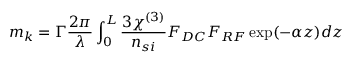Convert formula to latex. <formula><loc_0><loc_0><loc_500><loc_500>m _ { k } = \Gamma \frac { 2 \pi } { \lambda } \int _ { 0 } ^ { L } \frac { 3 \chi ^ { ( 3 ) } } { n _ { s i } } F _ { D C } F _ { R F } \exp ( - \alpha z ) d z</formula> 